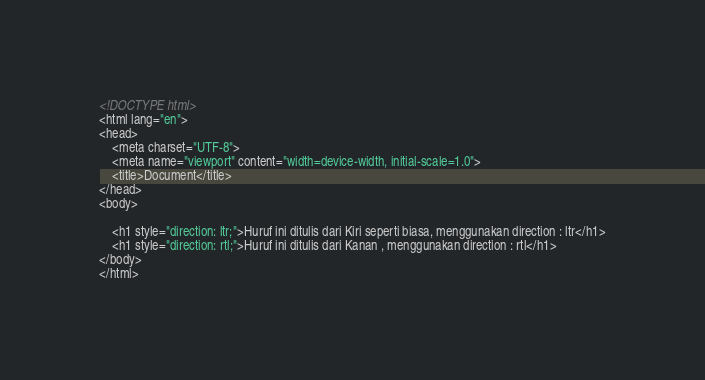Convert code to text. <code><loc_0><loc_0><loc_500><loc_500><_HTML_><!DOCTYPE html>
<html lang="en">
<head>
    <meta charset="UTF-8">
    <meta name="viewport" content="width=device-width, initial-scale=1.0">
    <title>Document</title>
</head>
<body>
    
    <h1 style="direction: ltr;">Huruf ini ditulis dari Kiri seperti biasa, menggunakan direction : ltr</h1>
    <h1 style="direction: rtl;">Huruf ini ditulis dari Kanan , menggunakan direction : rtl</h1>
</body>
</html></code> 